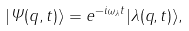<formula> <loc_0><loc_0><loc_500><loc_500>| \Psi ( q , t ) \rangle = e ^ { - i \omega _ { \lambda } t } | \lambda ( q , t ) \rangle ,</formula> 